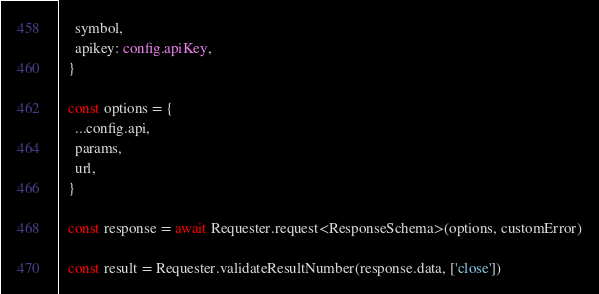Convert code to text. <code><loc_0><loc_0><loc_500><loc_500><_TypeScript_>    symbol,
    apikey: config.apiKey,
  }

  const options = {
    ...config.api,
    params,
    url,
  }

  const response = await Requester.request<ResponseSchema>(options, customError)

  const result = Requester.validateResultNumber(response.data, ['close'])
</code> 